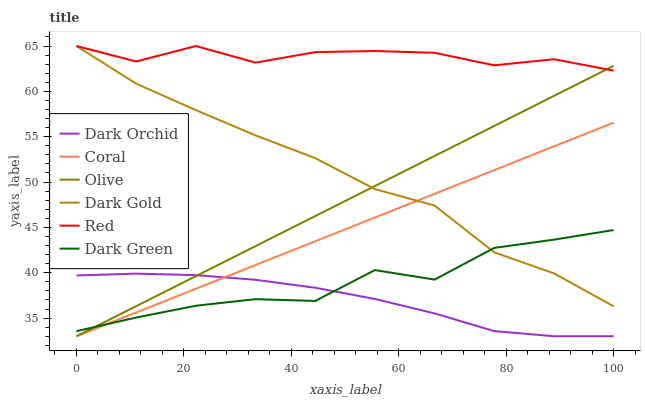Does Coral have the minimum area under the curve?
Answer yes or no. No. Does Coral have the maximum area under the curve?
Answer yes or no. No. Is Dark Orchid the smoothest?
Answer yes or no. No. Is Dark Orchid the roughest?
Answer yes or no. No. Does Red have the lowest value?
Answer yes or no. No. Does Coral have the highest value?
Answer yes or no. No. Is Dark Orchid less than Dark Gold?
Answer yes or no. Yes. Is Red greater than Dark Orchid?
Answer yes or no. Yes. Does Dark Orchid intersect Dark Gold?
Answer yes or no. No. 